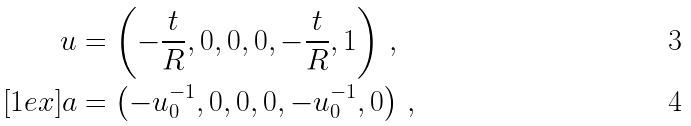<formula> <loc_0><loc_0><loc_500><loc_500>u & = \left ( - \frac { t } { R } , 0 , 0 , 0 , - \frac { t } { R } , 1 \right ) \, , \\ [ 1 e x ] a & = \left ( - u _ { 0 } ^ { - 1 } , 0 , 0 , 0 , - u _ { 0 } ^ { - 1 } , 0 \right ) \, ,</formula> 